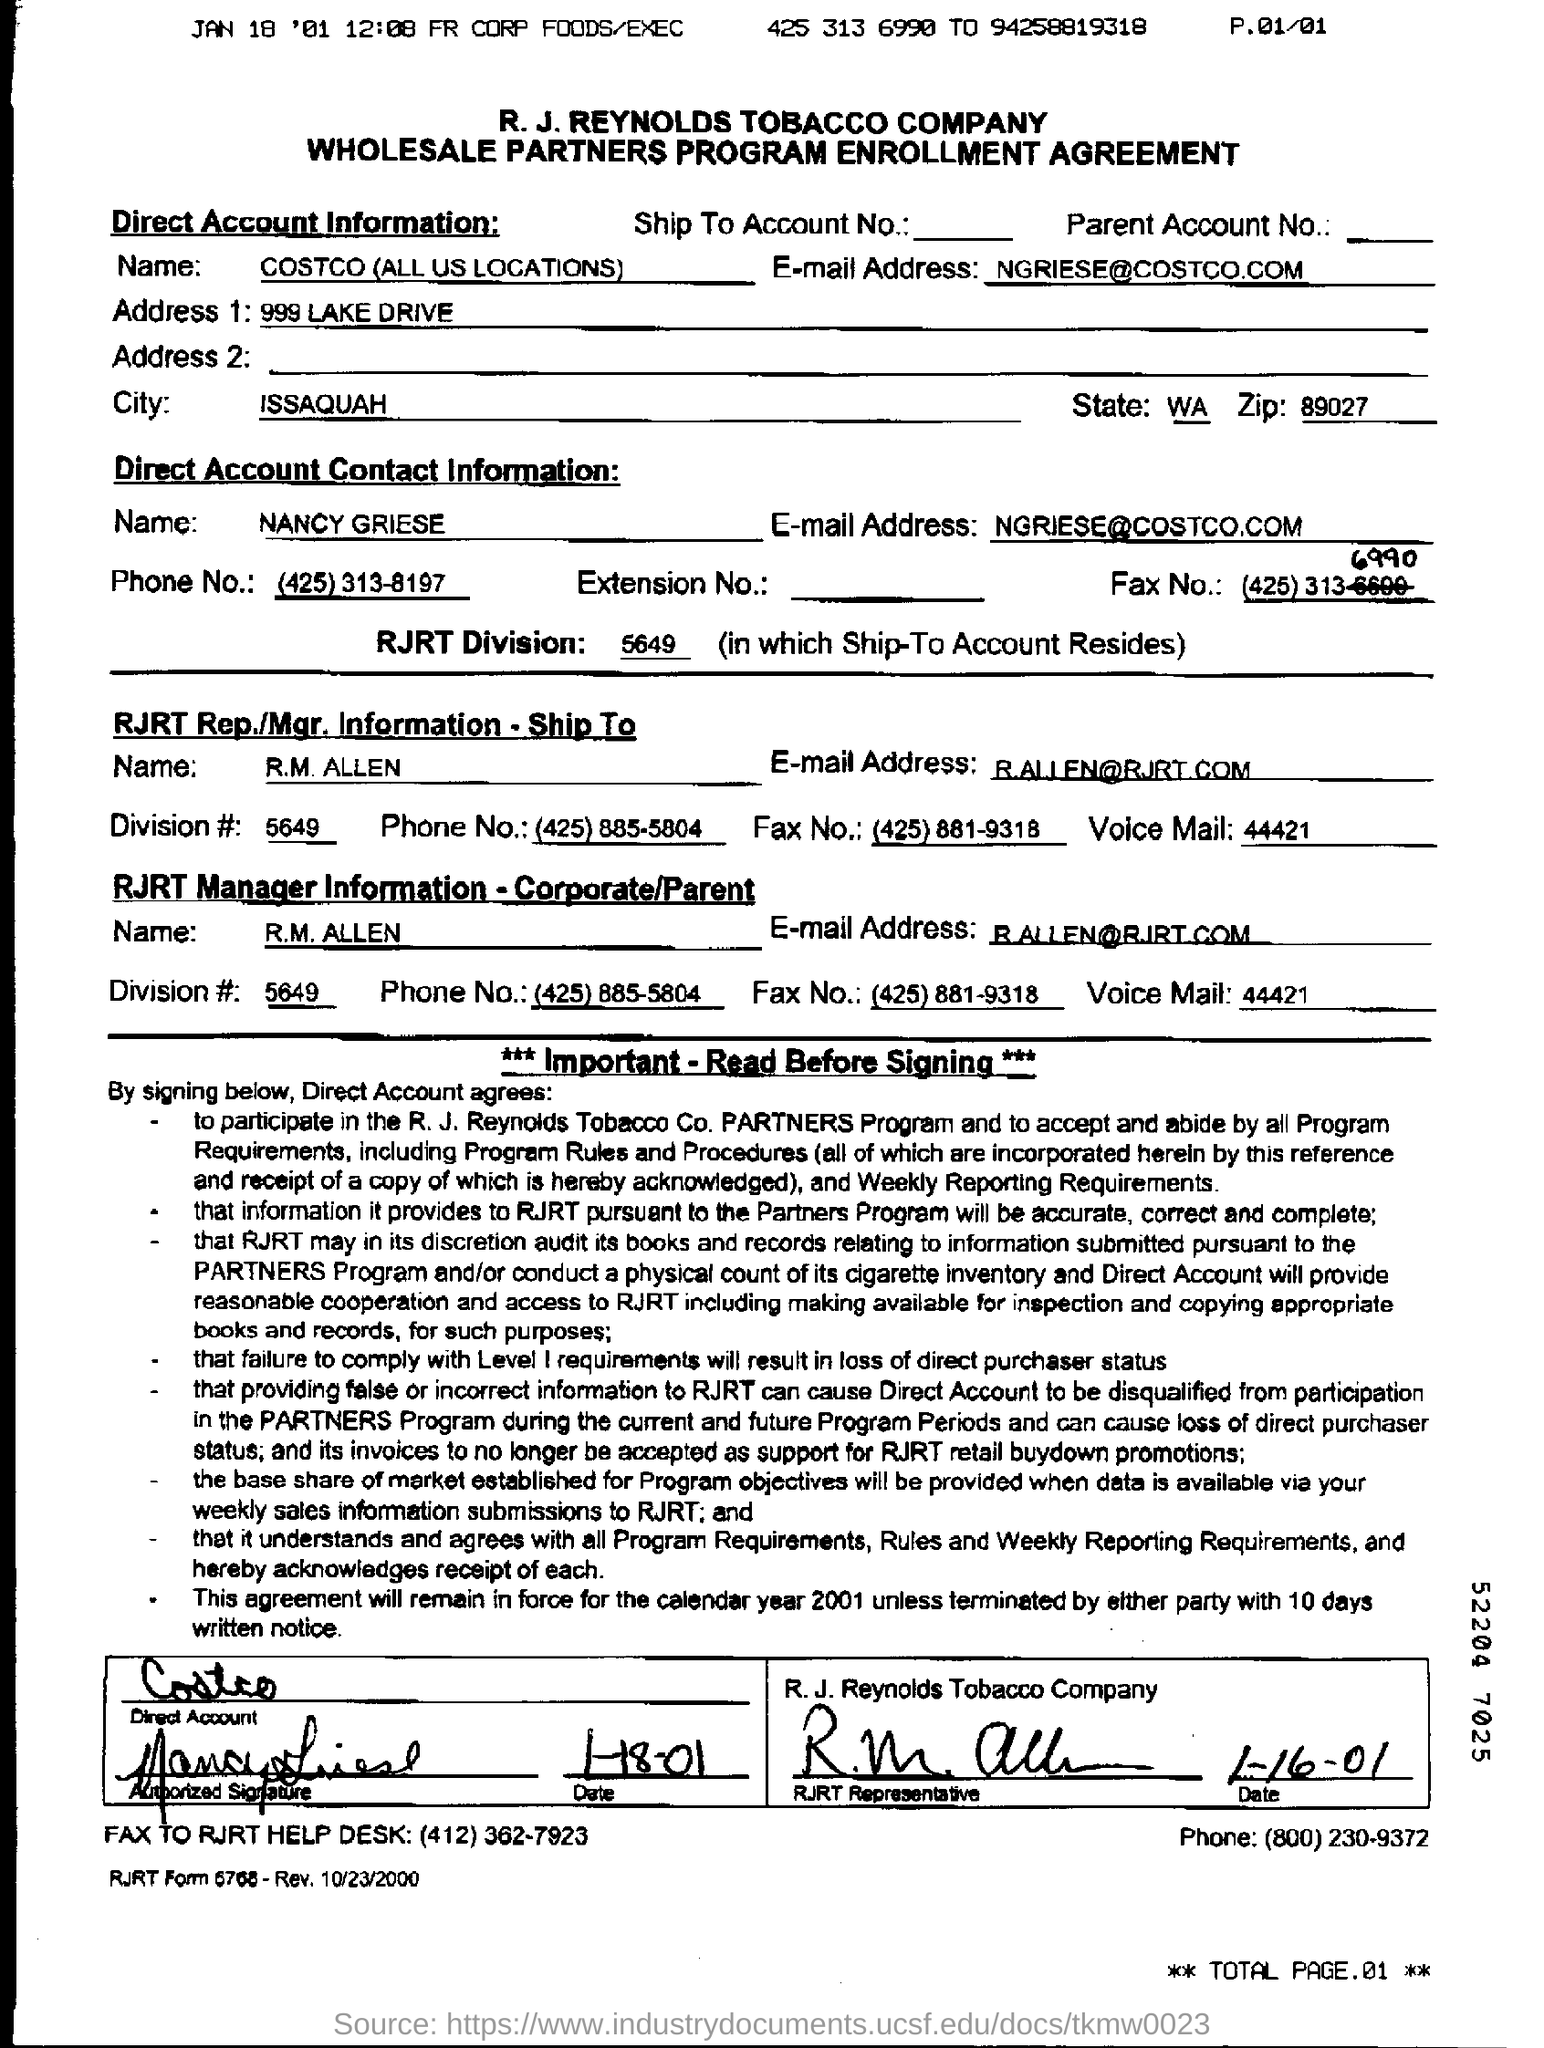1. Which company's name is mentioned in the document?
Your answer should be very brief. 4. Where is the address located?. 